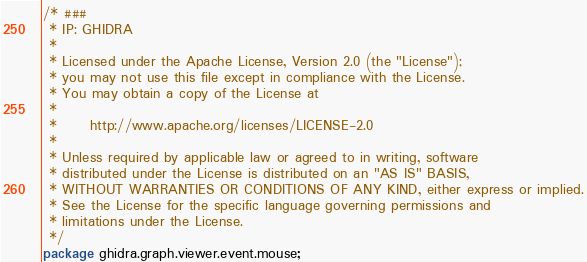<code> <loc_0><loc_0><loc_500><loc_500><_Java_>/* ###
 * IP: GHIDRA
 *
 * Licensed under the Apache License, Version 2.0 (the "License");
 * you may not use this file except in compliance with the License.
 * You may obtain a copy of the License at
 * 
 *      http://www.apache.org/licenses/LICENSE-2.0
 * 
 * Unless required by applicable law or agreed to in writing, software
 * distributed under the License is distributed on an "AS IS" BASIS,
 * WITHOUT WARRANTIES OR CONDITIONS OF ANY KIND, either express or implied.
 * See the License for the specific language governing permissions and
 * limitations under the License.
 */
package ghidra.graph.viewer.event.mouse;
</code> 